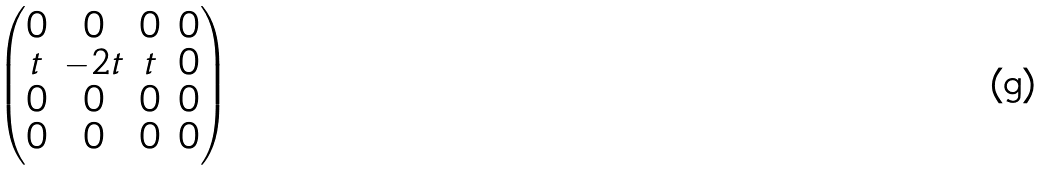Convert formula to latex. <formula><loc_0><loc_0><loc_500><loc_500>\begin{pmatrix} 0 & 0 & 0 & 0 \\ t & - 2 t & t & 0 \\ 0 & 0 & 0 & 0 \\ 0 & 0 & 0 & 0 \end{pmatrix}</formula> 